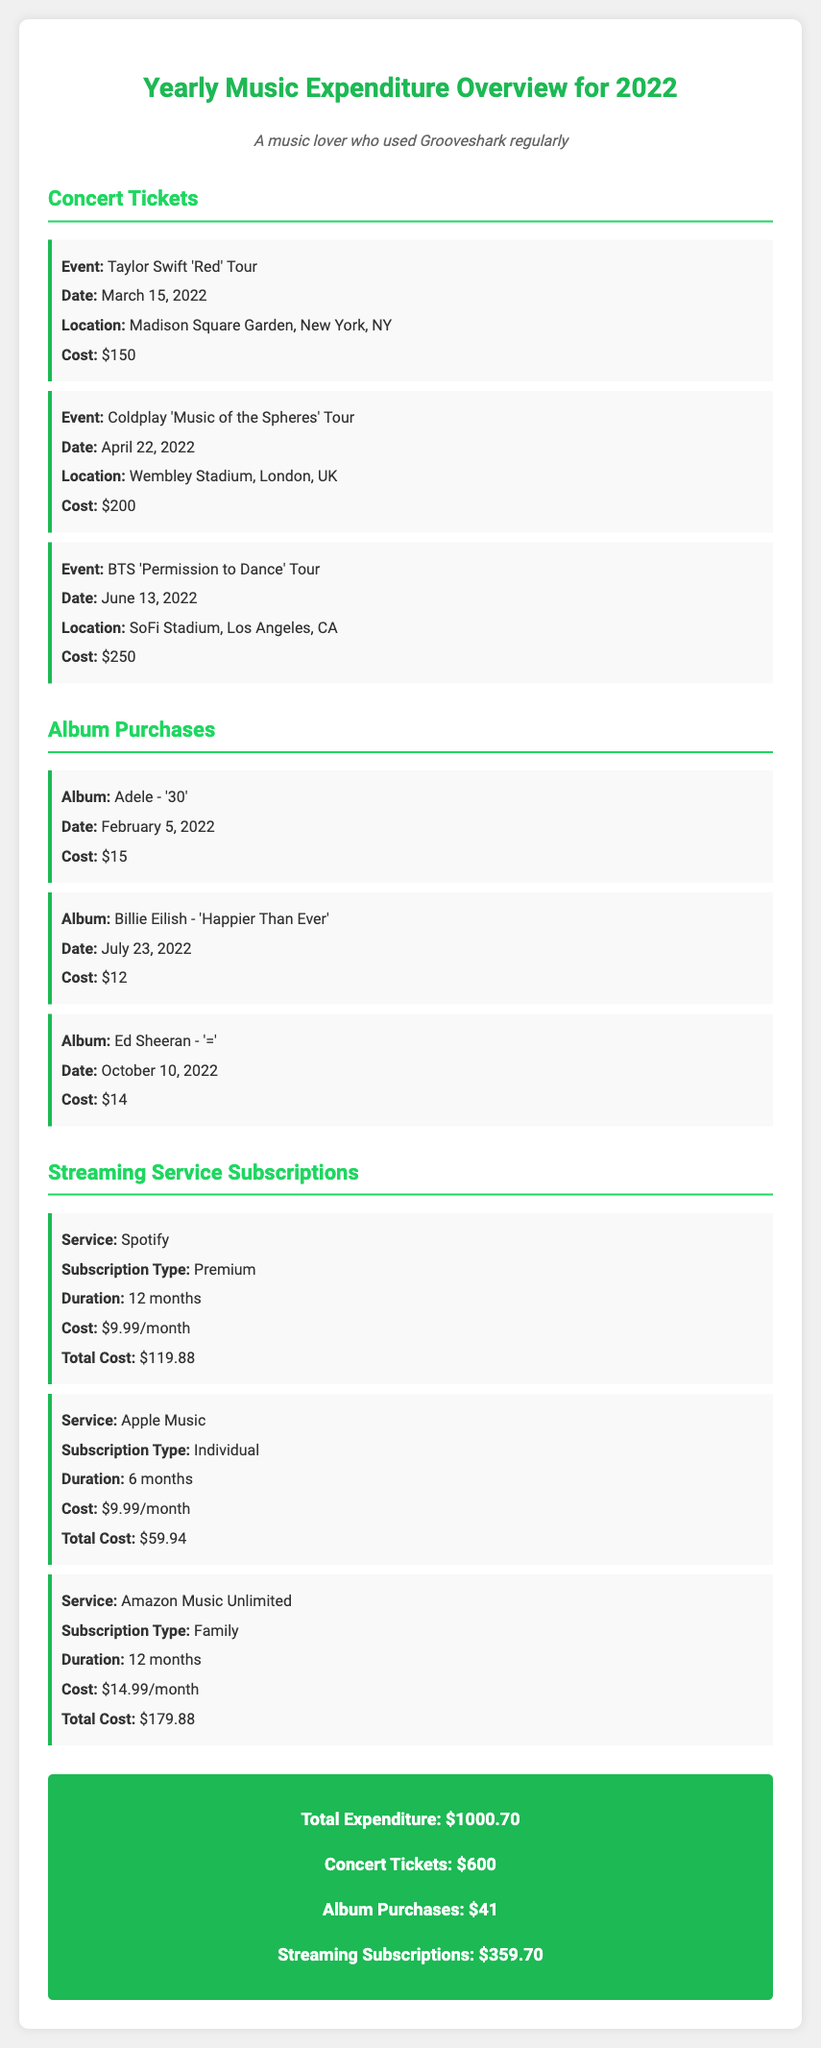What is the total expenditure for the year? The total expenditure is presented at the end of the document, summarizing all music-related purchases for the year 2022.
Answer: $1000.70 How much was spent on concert tickets? The expenditure on concert tickets is detailed in the concert section of the document.
Answer: $600 Which artist's tour occurred on March 15, 2022? The document lists specific concert events and their dates, including this artist's tour.
Answer: Taylor Swift 'Red' Tour What is the cost of the album '30' by Adele? The album purchases section provides individual costs for each album purchased throughout the year.
Answer: $15 How many months was the Spotify subscription? The document specifies the duration of the Spotify subscription under the streaming services section.
Answer: 12 months Which streaming service cost $179.88 for 12 months? The total costs for each streaming service purchase help identify its pricing structure in the document.
Answer: Amazon Music Unlimited What event took place at Wembley Stadium? The document lists concert events along with their locations, making this information retrievable.
Answer: Coldplay 'Music of the Spheres' Tour How many albums were purchased in total? The document lists each album purchase, allowing for a quick count of the entries.
Answer: 3 What was the total cost for album purchases? The total just for album purchases is summarized in the total expenditure section.
Answer: $41 